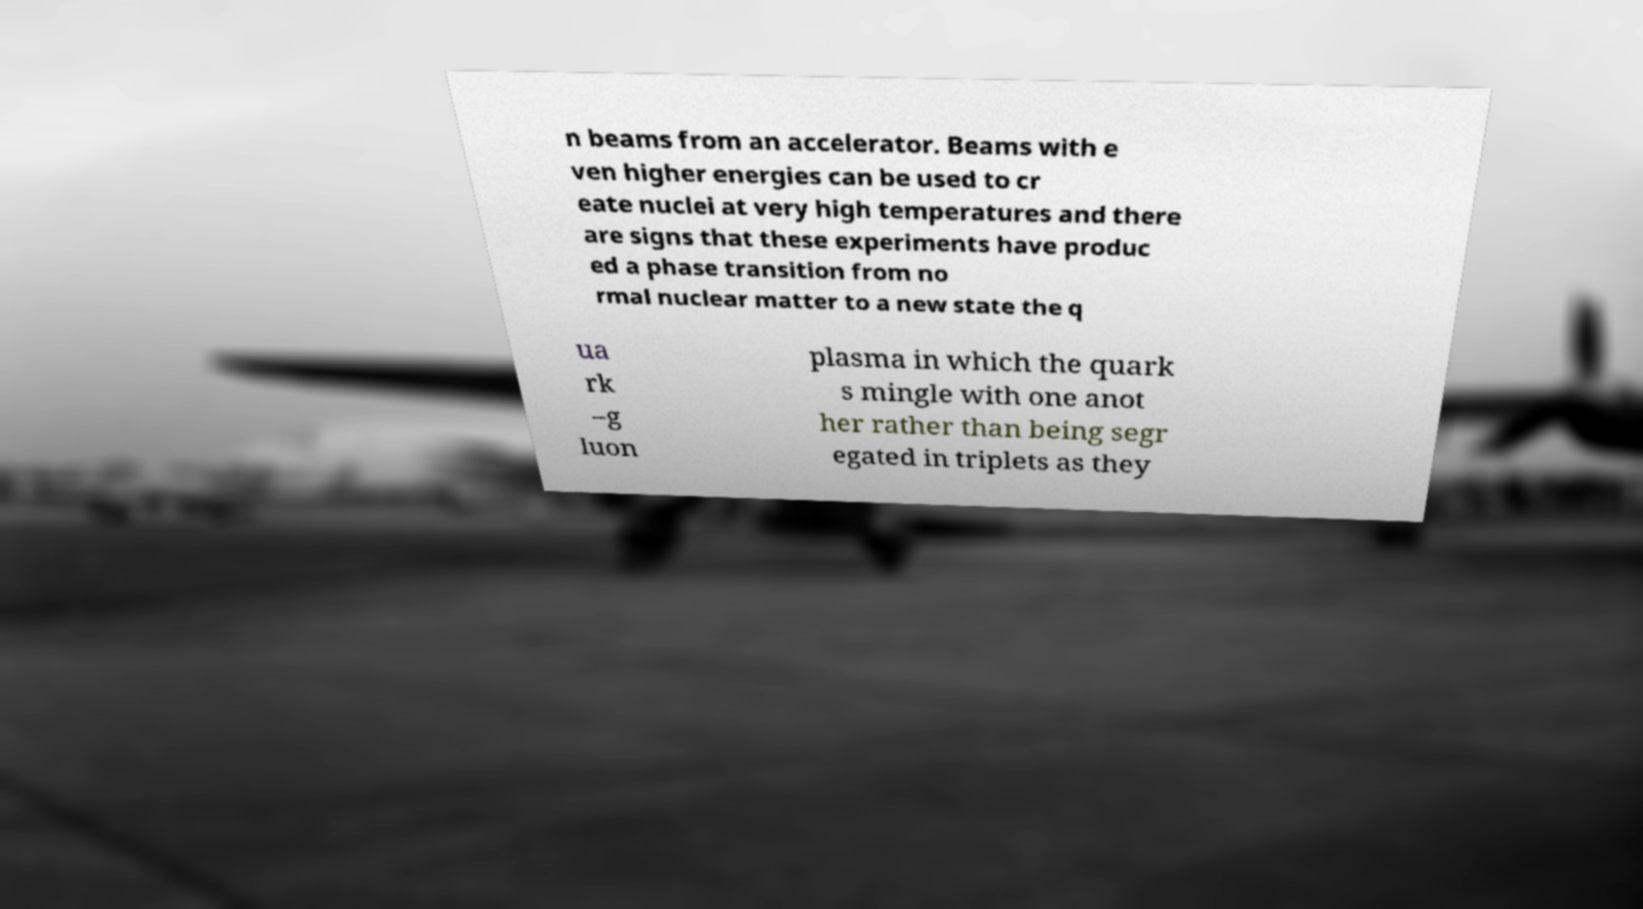Can you read and provide the text displayed in the image?This photo seems to have some interesting text. Can you extract and type it out for me? n beams from an accelerator. Beams with e ven higher energies can be used to cr eate nuclei at very high temperatures and there are signs that these experiments have produc ed a phase transition from no rmal nuclear matter to a new state the q ua rk –g luon plasma in which the quark s mingle with one anot her rather than being segr egated in triplets as they 